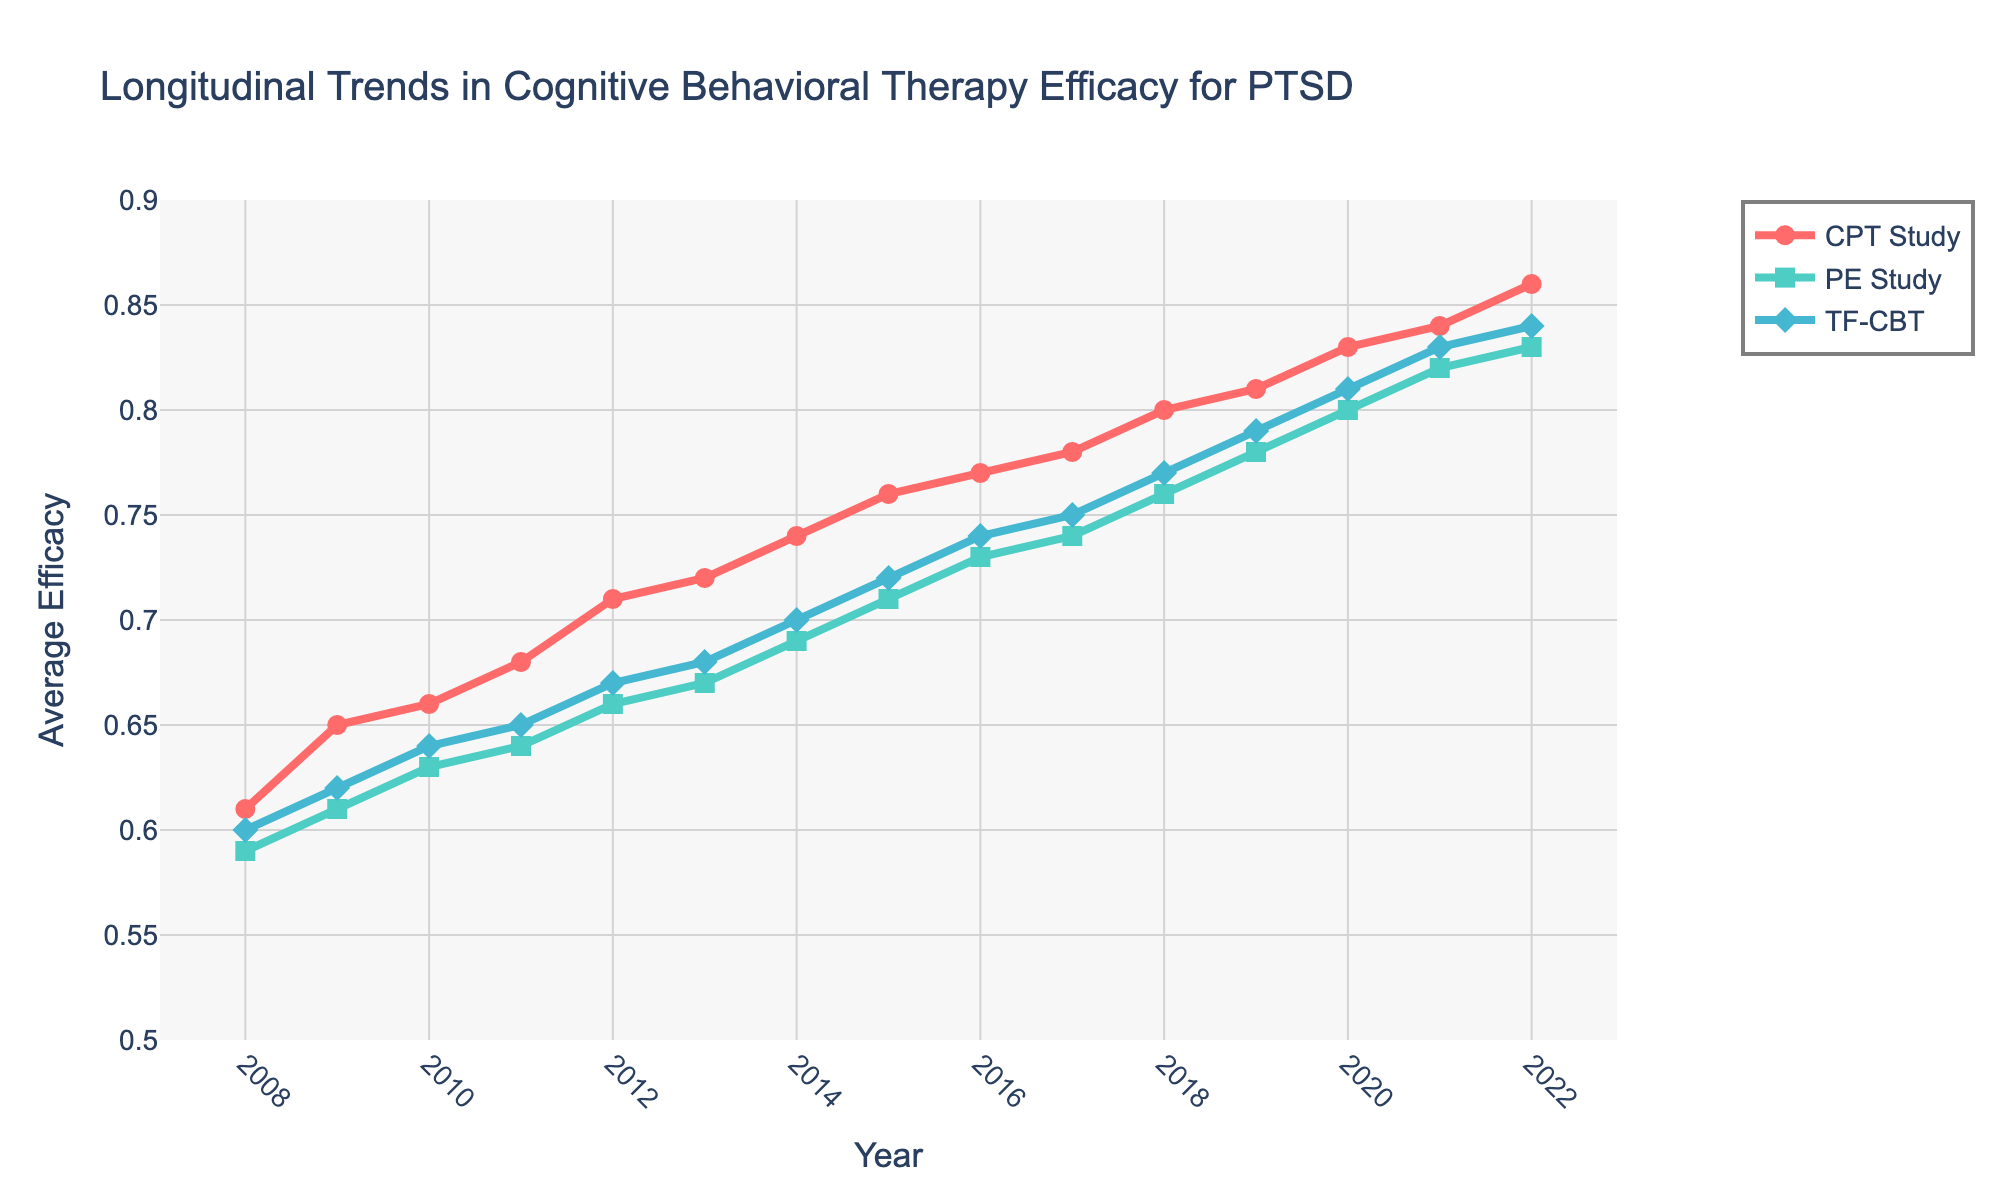What is the average efficacy of TF-CBT in the year 2018? Locate the data point for 2018 on the x-axis and then check the corresponding y-value for TF-CBT (marked with a diamond symbol).
Answer: 0.77 Between which years did the efficacy of CPT study increase the most? Check the difference in efficacy values for CPT study between each consecutive year and identify the largest increase. The efficacy increases the most between 2020 (0.83) and 2021 (0.84).
Answer: 2020 and 2021 What is the color used for the PE study line? Look for the visual color representation of the PE study line in the plot's legend.
Answer: Teal How many years of data are represented in the plot? Count the number of data points along the x-axis, which represent each year.
Answer: 15 When did TF-CBT efficacy first reach 0.80 or higher? Examine the TF-CBT efficacy values over the years and identify the first year it reaches 0.80 or higher.
Answer: 2019 Which study had the highest average efficacy in 2022? Check the efficacy values for all three studies in 2022 and determine which one is the highest.
Answer: CPT Study By how much did the efficacy of PE study increase from 2008 to 2022? Subtract the efficacy value of PE study in 2008 from its efficacy value in 2022 (0.83 - 0.59).
Answer: 0.24 What is the plot title? Read the main title at the top of the plot.
Answer: Longitudinal Trends in Cognitive Behavioral Therapy Efficacy for PTSD Which study showed the most consistent increase in efficacy over the years? Inspect all three study lines and determine which one shows a steady upward trend without any significant dips.
Answer: CPT Study 